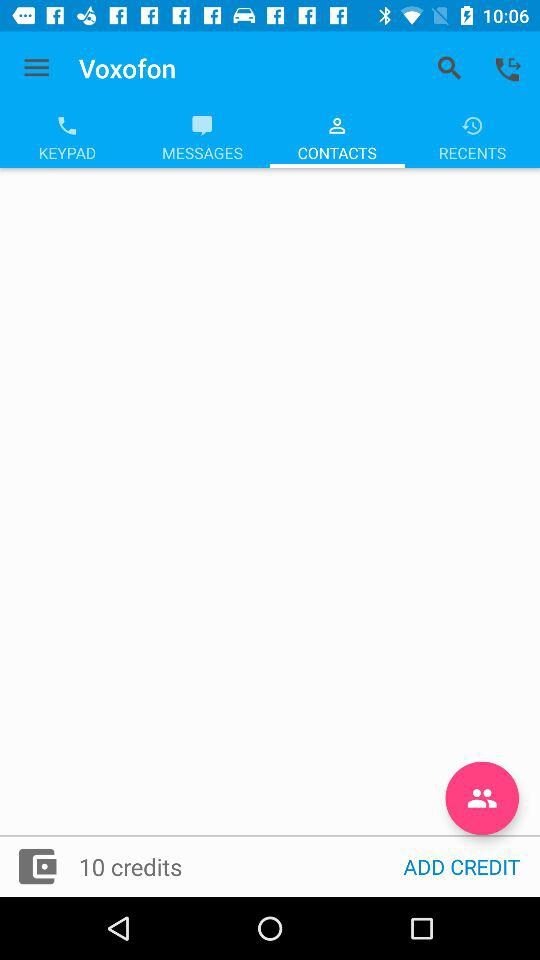Which tab is selected? The selected tab is "CONTACTS". 